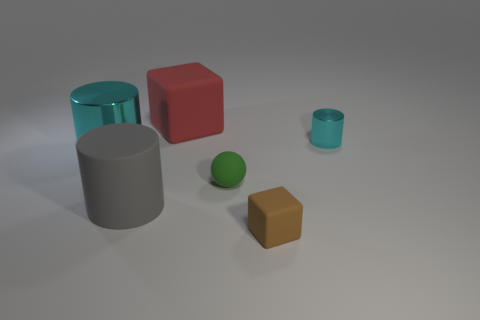Add 3 large cyan things. How many objects exist? 9 Subtract all balls. How many objects are left? 5 Subtract all yellow blocks. Subtract all small shiny objects. How many objects are left? 5 Add 2 large red matte cubes. How many large red matte cubes are left? 3 Add 5 gray matte cylinders. How many gray matte cylinders exist? 6 Subtract 0 purple cylinders. How many objects are left? 6 